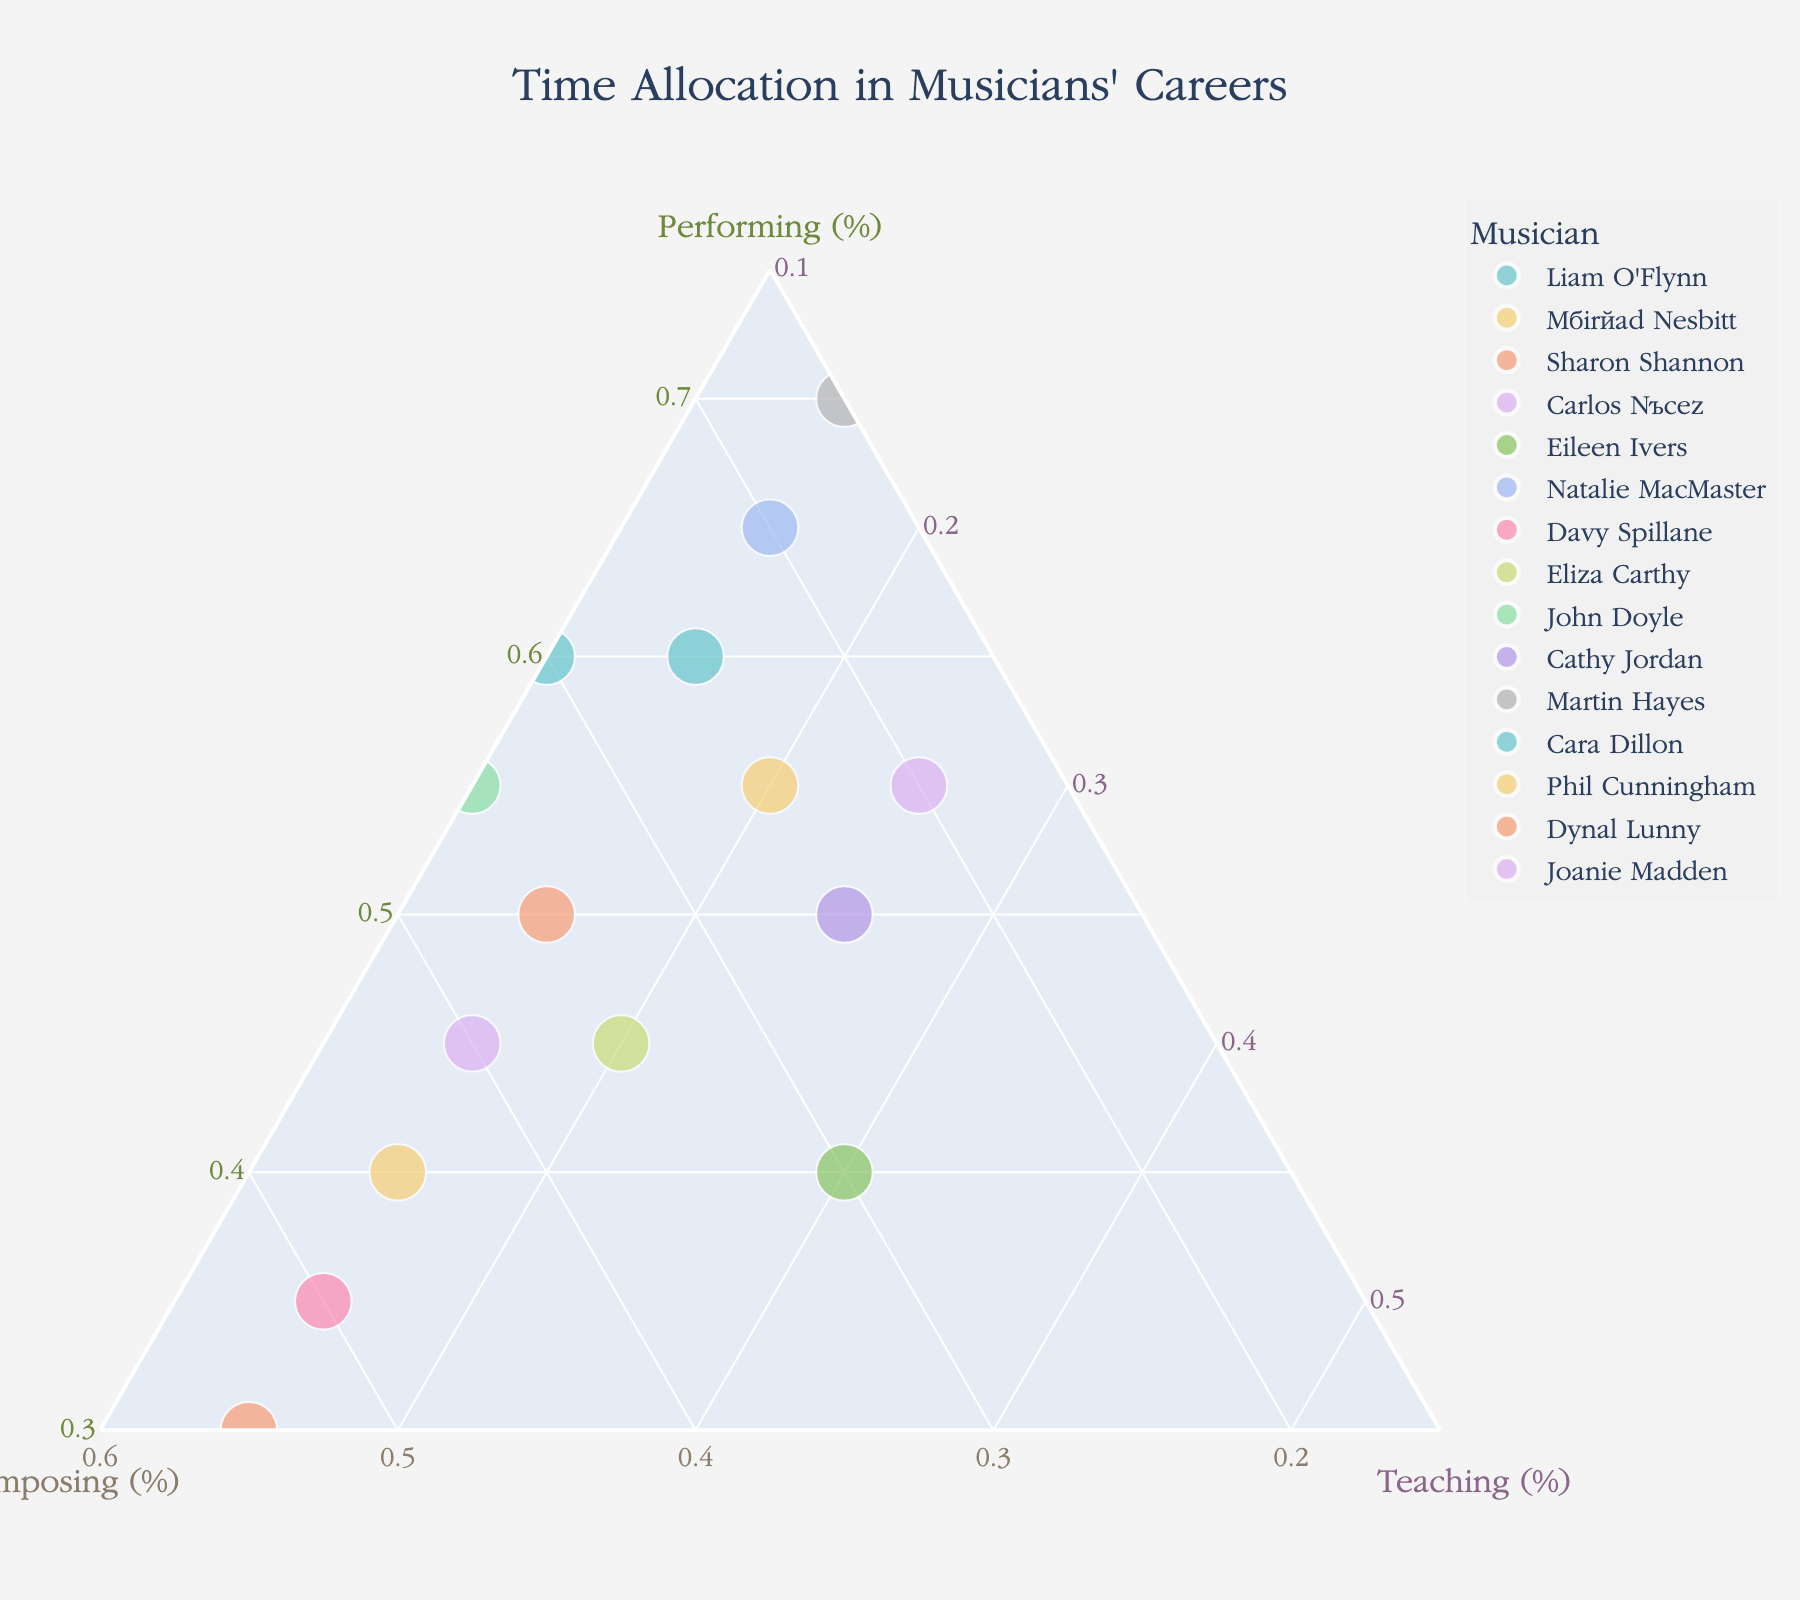What is the title of the figure? The title of the figure is typically displayed at the top center. It summarizes what the figure is about. Look for the largest text on the plot.
Answer: Time Allocation in Musicians' Careers Which musician allocates the most time to performing? To find this, look at the apex of the triangle labeled "Performing (%)" and identify the musician plotted closest towards the 100% mark.
Answer: Martin Hayes How many musicians allocate at least 50% of their time to performing? Count the number of points near the "Performing (%)" apex that have 50% or more time allocated to performing.
Answer: 8 Are there any musicians that allocate an equal percentage of time to two activities? Evaluate the points' positions to see if any are equidistant from two vertices, implying equal allocation to those two activities.
Answer: Yes, Eileen Ivers allocates 30% to both performing and teaching How does Sharon Shannon's time spent on composing compare to Carlos Núñez's? Locate Sharon Shannon and Carlos Núñez on the plot. Compare their distances from the "Composing (%)" apex. Sharon Shannon allocates 35%, while Carlos Núñez allocates 40%.
Answer: Carlos Núñez Which musician has the most balanced allocation (most equal) between performing, composing, and teaching? Look for the point closest to the center of the triangle, as this indicates a balanced allocation.
Answer: Eileen Ivers What is the range of time spent composing among the musicians? Identify the highest and lowest percentages in the "Composing (%)" axis. The highest is 55% by Dónal Lunny, and the lowest is 15% by Martin Hayes and Natalie MacMaster.
Answer: 15%-55% Are there any musicians who allocate more than 25% but less than 35% of their time to teaching? If yes, who are they? Check the points closest to the "Teaching (%)" apex for those within the 25%-35% range.
Answer: Joanie Madden Between Davy Spillane and Dónal Lunny, who allocates more time to teaching? Compare their positions relative to the "Teaching (%)" axis. Both allocate 15% of their time to teaching.
Answer: Both Is there any musician who allocates more time to teaching than to performing? Compare the musicians' distances from the "Performing (%)" and "Teaching (%)" apices.
Answer: No 